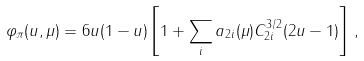Convert formula to latex. <formula><loc_0><loc_0><loc_500><loc_500>\varphi _ { \pi } ( u , \mu ) = 6 u ( 1 - u ) \left [ 1 + \sum _ { i } a _ { 2 i } ( \mu ) C ^ { 3 / 2 } _ { 2 i } ( 2 u - 1 ) \right ] \, ,</formula> 